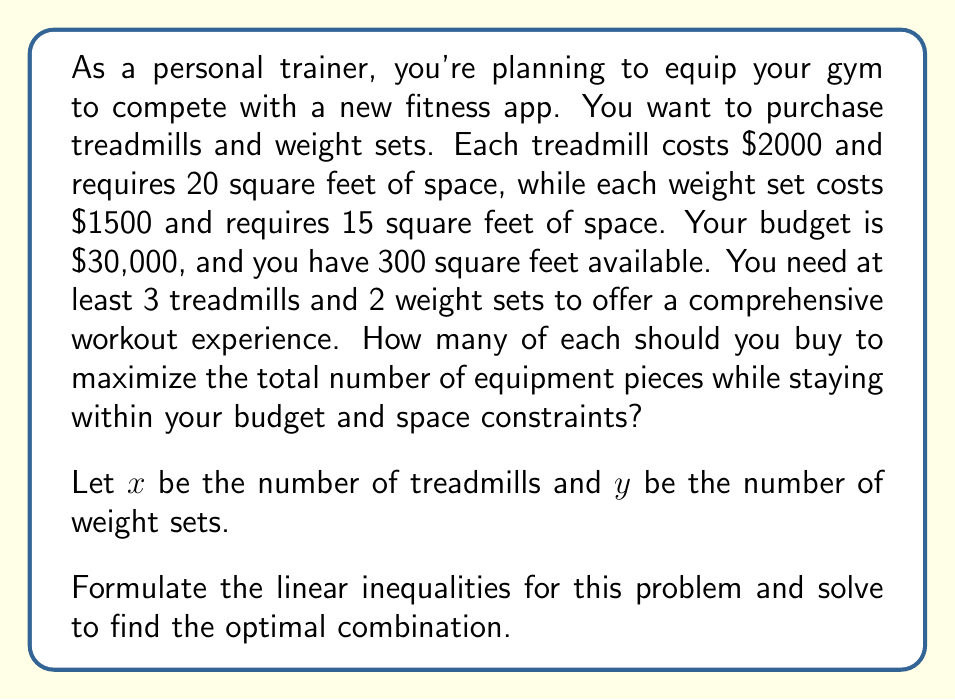Show me your answer to this math problem. Let's break this down step-by-step:

1. Define the variables:
   $x$ = number of treadmills
   $y$ = number of weight sets

2. Set up the inequalities:
   
   Budget constraint: $2000x + 1500y \leq 30000$
   Space constraint: $20x + 15y \leq 300$
   Minimum equipment: $x \geq 3$ and $y \geq 2$
   Non-negativity: $x \geq 0$ and $y \geq 0$

3. Simplify the budget and space constraints:
   
   $4x + 3y \leq 60$ (budget)
   $4x + 3y \leq 60$ (space)

4. Plot these inequalities:

   [asy]
   import geometry;
   
   size(200);
   
   xaxis("x", 0, 15);
   yaxis("y", 0, 20);
   
   path budget = (0,20)--(15,0);
   path space = (0,20)--(15,0);
   path minx = (3,0)--(3,20);
   path miny = (0,2)--(15,2);
   
   draw(budget, blue);
   draw(space, red);
   draw(minx, green);
   draw(miny, purple);
   
   label("Budget & Space", (7.5,10), NE);
   label("x ≥ 3", (3,10), W);
   label("y ≥ 2", (7.5,2), S);
   
   fill((3,2)--(15,2)--(9,10)--(3,10)--cycle, palegreen+opacity(0.2));
   
   dot((3,14), red);
   dot((9,10), red);
   dot((12,4), red);
   
   label("(3,14)", (3,14), NE);
   label("(9,10)", (9,10), NE);
   label("(12,4)", (12,4), SE);
   [/asy]

5. The feasible region is the shaded area. The optimal solution will be at one of the corner points of this region.

6. Corner points to consider:
   (3,14), (9,10), (12,4)

7. Calculate total equipment for each point:
   (3,14): 3 + 14 = 17
   (9,10): 9 + 10 = 19
   (12,4): 12 + 4 = 16

Therefore, the optimal solution is (9,10), which means 9 treadmills and 10 weight sets.
Answer: The optimal combination is 9 treadmills and 10 weight sets, for a total of 19 pieces of equipment. 